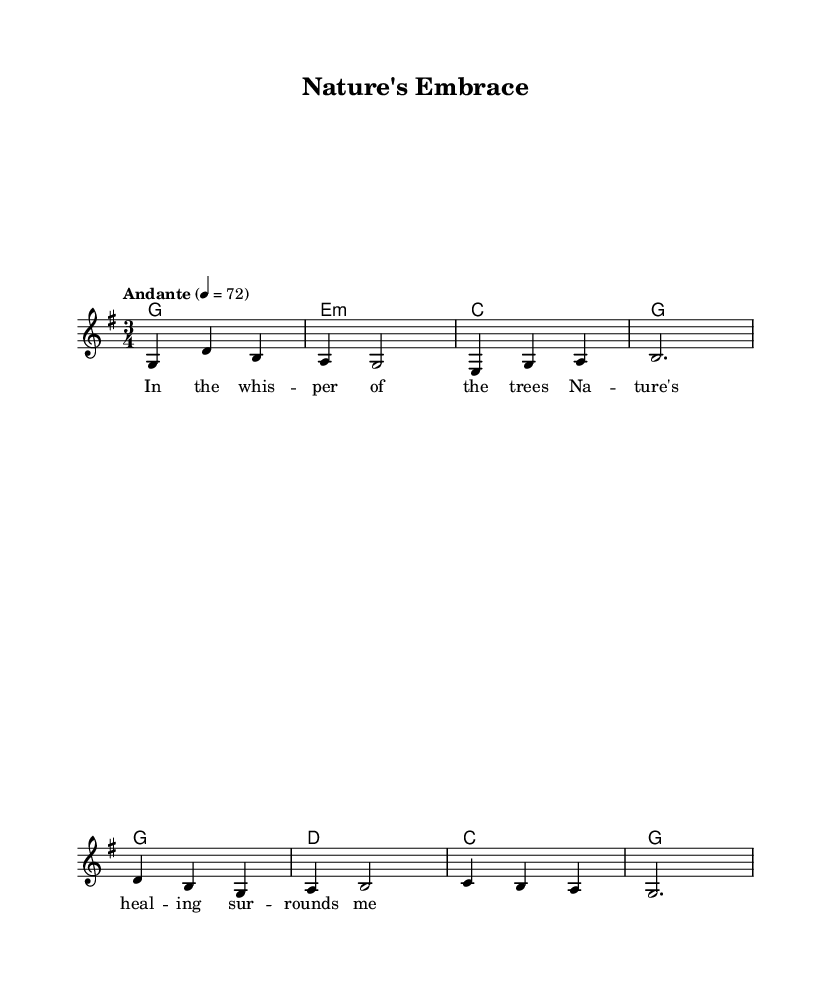What is the key signature of this music? The key signature is G major, which has one sharp (F#). This can be identified by looking at the beginning of the staff where the sharp is indicated.
Answer: G major What is the time signature of this piece? The time signature is 3/4, which indicates that there are three beats in each measure and the quarter note gets one beat. This is visible at the beginning of the score where the time signature is displayed.
Answer: 3/4 What tempo marking is given for this piece? The tempo marking is "Andante", which means to play at a moderately slow pace. This is noted at the beginning of the score next to the tempo indication.
Answer: Andante How many measures are in the melody section? There are eight measures in the melody section. We determine this by counting the distinct groupings of notes that appear within the melody part.
Answer: Eight What is the last note of the melody in the first line? The last note of the melody in the first line is a half note "b". This is identified by examining the melodic line and looking at the notation at the end of the first line.
Answer: B What chord is played over the lyrics "Na -- ture's heal -- ing sur -- rounds me"? The chord played over that lyric line is C major. This can be deduced by checking the chord symbols indicated above the corresponding lyrics in the score.
Answer: C major What musical form is being used in this piece? The musical form used in this piece is likely verse-refrain, as indicated by the structure of the lyrics and chord progressions that typically suggest repetition and variation.
Answer: Verse-refrain 